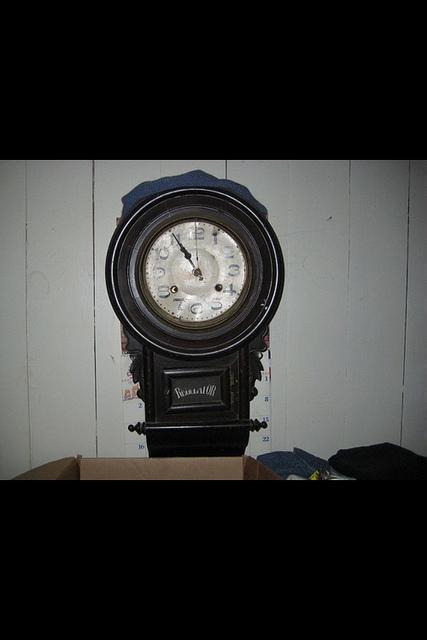How many of the pizzas have green vegetables?
Give a very brief answer. 0. 